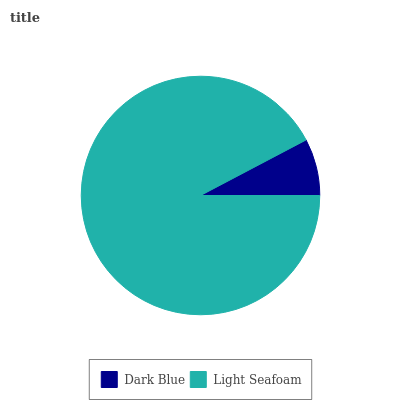Is Dark Blue the minimum?
Answer yes or no. Yes. Is Light Seafoam the maximum?
Answer yes or no. Yes. Is Light Seafoam the minimum?
Answer yes or no. No. Is Light Seafoam greater than Dark Blue?
Answer yes or no. Yes. Is Dark Blue less than Light Seafoam?
Answer yes or no. Yes. Is Dark Blue greater than Light Seafoam?
Answer yes or no. No. Is Light Seafoam less than Dark Blue?
Answer yes or no. No. Is Light Seafoam the high median?
Answer yes or no. Yes. Is Dark Blue the low median?
Answer yes or no. Yes. Is Dark Blue the high median?
Answer yes or no. No. Is Light Seafoam the low median?
Answer yes or no. No. 